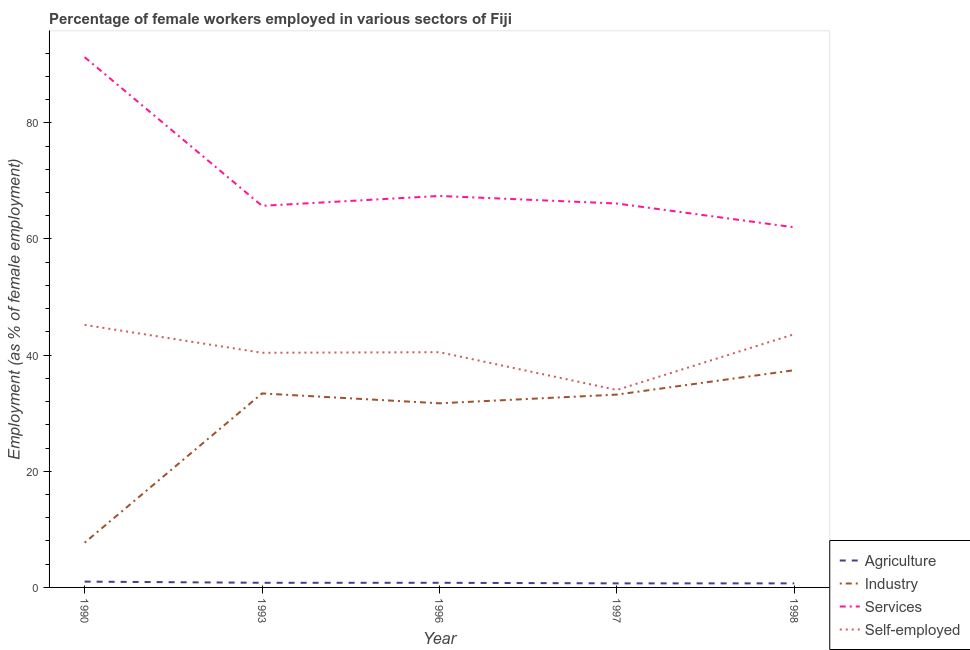How many different coloured lines are there?
Provide a short and direct response. 4. Is the number of lines equal to the number of legend labels?
Offer a terse response. Yes. What is the percentage of female workers in industry in 1998?
Offer a very short reply. 37.4. Across all years, what is the maximum percentage of self employed female workers?
Keep it short and to the point. 45.2. Across all years, what is the minimum percentage of female workers in agriculture?
Ensure brevity in your answer.  0.7. In which year was the percentage of female workers in services minimum?
Provide a short and direct response. 1998. What is the total percentage of female workers in services in the graph?
Give a very brief answer. 352.5. What is the difference between the percentage of self employed female workers in 1990 and that in 1996?
Keep it short and to the point. 4.7. What is the difference between the percentage of female workers in services in 1993 and the percentage of female workers in agriculture in 1990?
Offer a very short reply. 64.7. What is the average percentage of self employed female workers per year?
Give a very brief answer. 40.74. In the year 1993, what is the difference between the percentage of female workers in industry and percentage of female workers in services?
Keep it short and to the point. -32.3. In how many years, is the percentage of female workers in industry greater than 84 %?
Your response must be concise. 0. Is the percentage of female workers in industry in 1990 less than that in 1996?
Provide a short and direct response. Yes. Is the difference between the percentage of female workers in agriculture in 1996 and 1997 greater than the difference between the percentage of self employed female workers in 1996 and 1997?
Ensure brevity in your answer.  No. What is the difference between the highest and the second highest percentage of self employed female workers?
Keep it short and to the point. 1.6. What is the difference between the highest and the lowest percentage of female workers in agriculture?
Your answer should be very brief. 0.3. Is it the case that in every year, the sum of the percentage of self employed female workers and percentage of female workers in services is greater than the sum of percentage of female workers in agriculture and percentage of female workers in industry?
Make the answer very short. Yes. Is the percentage of female workers in industry strictly less than the percentage of female workers in agriculture over the years?
Ensure brevity in your answer.  No. What is the difference between two consecutive major ticks on the Y-axis?
Give a very brief answer. 20. Does the graph contain any zero values?
Your response must be concise. No. Does the graph contain grids?
Keep it short and to the point. No. How are the legend labels stacked?
Keep it short and to the point. Vertical. What is the title of the graph?
Your answer should be compact. Percentage of female workers employed in various sectors of Fiji. Does "Miscellaneous expenses" appear as one of the legend labels in the graph?
Your answer should be compact. No. What is the label or title of the Y-axis?
Keep it short and to the point. Employment (as % of female employment). What is the Employment (as % of female employment) of Agriculture in 1990?
Make the answer very short. 1. What is the Employment (as % of female employment) of Industry in 1990?
Make the answer very short. 7.7. What is the Employment (as % of female employment) of Services in 1990?
Ensure brevity in your answer.  91.3. What is the Employment (as % of female employment) in Self-employed in 1990?
Ensure brevity in your answer.  45.2. What is the Employment (as % of female employment) in Agriculture in 1993?
Make the answer very short. 0.8. What is the Employment (as % of female employment) in Industry in 1993?
Provide a succinct answer. 33.4. What is the Employment (as % of female employment) in Services in 1993?
Keep it short and to the point. 65.7. What is the Employment (as % of female employment) in Self-employed in 1993?
Offer a very short reply. 40.4. What is the Employment (as % of female employment) in Agriculture in 1996?
Make the answer very short. 0.8. What is the Employment (as % of female employment) of Industry in 1996?
Your answer should be very brief. 31.7. What is the Employment (as % of female employment) of Services in 1996?
Keep it short and to the point. 67.4. What is the Employment (as % of female employment) of Self-employed in 1996?
Your answer should be compact. 40.5. What is the Employment (as % of female employment) in Agriculture in 1997?
Keep it short and to the point. 0.7. What is the Employment (as % of female employment) in Industry in 1997?
Offer a very short reply. 33.2. What is the Employment (as % of female employment) of Services in 1997?
Provide a short and direct response. 66.1. What is the Employment (as % of female employment) of Self-employed in 1997?
Provide a short and direct response. 34. What is the Employment (as % of female employment) of Agriculture in 1998?
Provide a short and direct response. 0.7. What is the Employment (as % of female employment) in Industry in 1998?
Your answer should be very brief. 37.4. What is the Employment (as % of female employment) in Services in 1998?
Provide a succinct answer. 62. What is the Employment (as % of female employment) in Self-employed in 1998?
Make the answer very short. 43.6. Across all years, what is the maximum Employment (as % of female employment) of Industry?
Your response must be concise. 37.4. Across all years, what is the maximum Employment (as % of female employment) of Services?
Provide a short and direct response. 91.3. Across all years, what is the maximum Employment (as % of female employment) of Self-employed?
Provide a short and direct response. 45.2. Across all years, what is the minimum Employment (as % of female employment) in Agriculture?
Provide a short and direct response. 0.7. Across all years, what is the minimum Employment (as % of female employment) in Industry?
Your answer should be compact. 7.7. Across all years, what is the minimum Employment (as % of female employment) in Services?
Give a very brief answer. 62. What is the total Employment (as % of female employment) in Industry in the graph?
Offer a terse response. 143.4. What is the total Employment (as % of female employment) in Services in the graph?
Make the answer very short. 352.5. What is the total Employment (as % of female employment) of Self-employed in the graph?
Provide a succinct answer. 203.7. What is the difference between the Employment (as % of female employment) in Industry in 1990 and that in 1993?
Provide a succinct answer. -25.7. What is the difference between the Employment (as % of female employment) of Services in 1990 and that in 1993?
Provide a succinct answer. 25.6. What is the difference between the Employment (as % of female employment) in Industry in 1990 and that in 1996?
Your answer should be compact. -24. What is the difference between the Employment (as % of female employment) of Services in 1990 and that in 1996?
Offer a very short reply. 23.9. What is the difference between the Employment (as % of female employment) of Industry in 1990 and that in 1997?
Keep it short and to the point. -25.5. What is the difference between the Employment (as % of female employment) of Services in 1990 and that in 1997?
Your answer should be compact. 25.2. What is the difference between the Employment (as % of female employment) in Self-employed in 1990 and that in 1997?
Give a very brief answer. 11.2. What is the difference between the Employment (as % of female employment) in Industry in 1990 and that in 1998?
Provide a short and direct response. -29.7. What is the difference between the Employment (as % of female employment) of Services in 1990 and that in 1998?
Your answer should be very brief. 29.3. What is the difference between the Employment (as % of female employment) of Self-employed in 1990 and that in 1998?
Offer a terse response. 1.6. What is the difference between the Employment (as % of female employment) of Industry in 1993 and that in 1996?
Your answer should be very brief. 1.7. What is the difference between the Employment (as % of female employment) in Services in 1993 and that in 1996?
Make the answer very short. -1.7. What is the difference between the Employment (as % of female employment) in Self-employed in 1993 and that in 1997?
Ensure brevity in your answer.  6.4. What is the difference between the Employment (as % of female employment) of Services in 1993 and that in 1998?
Provide a short and direct response. 3.7. What is the difference between the Employment (as % of female employment) in Services in 1996 and that in 1997?
Ensure brevity in your answer.  1.3. What is the difference between the Employment (as % of female employment) of Services in 1996 and that in 1998?
Provide a short and direct response. 5.4. What is the difference between the Employment (as % of female employment) of Agriculture in 1997 and that in 1998?
Keep it short and to the point. 0. What is the difference between the Employment (as % of female employment) in Agriculture in 1990 and the Employment (as % of female employment) in Industry in 1993?
Offer a terse response. -32.4. What is the difference between the Employment (as % of female employment) of Agriculture in 1990 and the Employment (as % of female employment) of Services in 1993?
Ensure brevity in your answer.  -64.7. What is the difference between the Employment (as % of female employment) of Agriculture in 1990 and the Employment (as % of female employment) of Self-employed in 1993?
Give a very brief answer. -39.4. What is the difference between the Employment (as % of female employment) in Industry in 1990 and the Employment (as % of female employment) in Services in 1993?
Make the answer very short. -58. What is the difference between the Employment (as % of female employment) in Industry in 1990 and the Employment (as % of female employment) in Self-employed in 1993?
Ensure brevity in your answer.  -32.7. What is the difference between the Employment (as % of female employment) in Services in 1990 and the Employment (as % of female employment) in Self-employed in 1993?
Make the answer very short. 50.9. What is the difference between the Employment (as % of female employment) in Agriculture in 1990 and the Employment (as % of female employment) in Industry in 1996?
Keep it short and to the point. -30.7. What is the difference between the Employment (as % of female employment) in Agriculture in 1990 and the Employment (as % of female employment) in Services in 1996?
Your response must be concise. -66.4. What is the difference between the Employment (as % of female employment) of Agriculture in 1990 and the Employment (as % of female employment) of Self-employed in 1996?
Ensure brevity in your answer.  -39.5. What is the difference between the Employment (as % of female employment) of Industry in 1990 and the Employment (as % of female employment) of Services in 1996?
Your answer should be compact. -59.7. What is the difference between the Employment (as % of female employment) of Industry in 1990 and the Employment (as % of female employment) of Self-employed in 1996?
Your answer should be compact. -32.8. What is the difference between the Employment (as % of female employment) of Services in 1990 and the Employment (as % of female employment) of Self-employed in 1996?
Provide a short and direct response. 50.8. What is the difference between the Employment (as % of female employment) of Agriculture in 1990 and the Employment (as % of female employment) of Industry in 1997?
Keep it short and to the point. -32.2. What is the difference between the Employment (as % of female employment) of Agriculture in 1990 and the Employment (as % of female employment) of Services in 1997?
Offer a very short reply. -65.1. What is the difference between the Employment (as % of female employment) in Agriculture in 1990 and the Employment (as % of female employment) in Self-employed in 1997?
Your answer should be very brief. -33. What is the difference between the Employment (as % of female employment) in Industry in 1990 and the Employment (as % of female employment) in Services in 1997?
Keep it short and to the point. -58.4. What is the difference between the Employment (as % of female employment) in Industry in 1990 and the Employment (as % of female employment) in Self-employed in 1997?
Keep it short and to the point. -26.3. What is the difference between the Employment (as % of female employment) in Services in 1990 and the Employment (as % of female employment) in Self-employed in 1997?
Offer a very short reply. 57.3. What is the difference between the Employment (as % of female employment) of Agriculture in 1990 and the Employment (as % of female employment) of Industry in 1998?
Give a very brief answer. -36.4. What is the difference between the Employment (as % of female employment) in Agriculture in 1990 and the Employment (as % of female employment) in Services in 1998?
Give a very brief answer. -61. What is the difference between the Employment (as % of female employment) in Agriculture in 1990 and the Employment (as % of female employment) in Self-employed in 1998?
Give a very brief answer. -42.6. What is the difference between the Employment (as % of female employment) in Industry in 1990 and the Employment (as % of female employment) in Services in 1998?
Your response must be concise. -54.3. What is the difference between the Employment (as % of female employment) in Industry in 1990 and the Employment (as % of female employment) in Self-employed in 1998?
Your answer should be compact. -35.9. What is the difference between the Employment (as % of female employment) in Services in 1990 and the Employment (as % of female employment) in Self-employed in 1998?
Provide a short and direct response. 47.7. What is the difference between the Employment (as % of female employment) of Agriculture in 1993 and the Employment (as % of female employment) of Industry in 1996?
Make the answer very short. -30.9. What is the difference between the Employment (as % of female employment) in Agriculture in 1993 and the Employment (as % of female employment) in Services in 1996?
Offer a very short reply. -66.6. What is the difference between the Employment (as % of female employment) in Agriculture in 1993 and the Employment (as % of female employment) in Self-employed in 1996?
Offer a very short reply. -39.7. What is the difference between the Employment (as % of female employment) of Industry in 1993 and the Employment (as % of female employment) of Services in 1996?
Offer a very short reply. -34. What is the difference between the Employment (as % of female employment) of Services in 1993 and the Employment (as % of female employment) of Self-employed in 1996?
Your response must be concise. 25.2. What is the difference between the Employment (as % of female employment) of Agriculture in 1993 and the Employment (as % of female employment) of Industry in 1997?
Your answer should be very brief. -32.4. What is the difference between the Employment (as % of female employment) in Agriculture in 1993 and the Employment (as % of female employment) in Services in 1997?
Offer a terse response. -65.3. What is the difference between the Employment (as % of female employment) in Agriculture in 1993 and the Employment (as % of female employment) in Self-employed in 1997?
Provide a short and direct response. -33.2. What is the difference between the Employment (as % of female employment) in Industry in 1993 and the Employment (as % of female employment) in Services in 1997?
Provide a succinct answer. -32.7. What is the difference between the Employment (as % of female employment) in Industry in 1993 and the Employment (as % of female employment) in Self-employed in 1997?
Offer a terse response. -0.6. What is the difference between the Employment (as % of female employment) in Services in 1993 and the Employment (as % of female employment) in Self-employed in 1997?
Provide a short and direct response. 31.7. What is the difference between the Employment (as % of female employment) in Agriculture in 1993 and the Employment (as % of female employment) in Industry in 1998?
Offer a very short reply. -36.6. What is the difference between the Employment (as % of female employment) of Agriculture in 1993 and the Employment (as % of female employment) of Services in 1998?
Offer a terse response. -61.2. What is the difference between the Employment (as % of female employment) of Agriculture in 1993 and the Employment (as % of female employment) of Self-employed in 1998?
Your answer should be compact. -42.8. What is the difference between the Employment (as % of female employment) of Industry in 1993 and the Employment (as % of female employment) of Services in 1998?
Your answer should be compact. -28.6. What is the difference between the Employment (as % of female employment) of Industry in 1993 and the Employment (as % of female employment) of Self-employed in 1998?
Provide a succinct answer. -10.2. What is the difference between the Employment (as % of female employment) in Services in 1993 and the Employment (as % of female employment) in Self-employed in 1998?
Ensure brevity in your answer.  22.1. What is the difference between the Employment (as % of female employment) in Agriculture in 1996 and the Employment (as % of female employment) in Industry in 1997?
Your answer should be compact. -32.4. What is the difference between the Employment (as % of female employment) in Agriculture in 1996 and the Employment (as % of female employment) in Services in 1997?
Keep it short and to the point. -65.3. What is the difference between the Employment (as % of female employment) of Agriculture in 1996 and the Employment (as % of female employment) of Self-employed in 1997?
Give a very brief answer. -33.2. What is the difference between the Employment (as % of female employment) of Industry in 1996 and the Employment (as % of female employment) of Services in 1997?
Offer a very short reply. -34.4. What is the difference between the Employment (as % of female employment) of Services in 1996 and the Employment (as % of female employment) of Self-employed in 1997?
Give a very brief answer. 33.4. What is the difference between the Employment (as % of female employment) of Agriculture in 1996 and the Employment (as % of female employment) of Industry in 1998?
Give a very brief answer. -36.6. What is the difference between the Employment (as % of female employment) of Agriculture in 1996 and the Employment (as % of female employment) of Services in 1998?
Your response must be concise. -61.2. What is the difference between the Employment (as % of female employment) in Agriculture in 1996 and the Employment (as % of female employment) in Self-employed in 1998?
Your answer should be compact. -42.8. What is the difference between the Employment (as % of female employment) of Industry in 1996 and the Employment (as % of female employment) of Services in 1998?
Offer a terse response. -30.3. What is the difference between the Employment (as % of female employment) in Industry in 1996 and the Employment (as % of female employment) in Self-employed in 1998?
Ensure brevity in your answer.  -11.9. What is the difference between the Employment (as % of female employment) of Services in 1996 and the Employment (as % of female employment) of Self-employed in 1998?
Your response must be concise. 23.8. What is the difference between the Employment (as % of female employment) in Agriculture in 1997 and the Employment (as % of female employment) in Industry in 1998?
Provide a short and direct response. -36.7. What is the difference between the Employment (as % of female employment) in Agriculture in 1997 and the Employment (as % of female employment) in Services in 1998?
Offer a terse response. -61.3. What is the difference between the Employment (as % of female employment) in Agriculture in 1997 and the Employment (as % of female employment) in Self-employed in 1998?
Offer a terse response. -42.9. What is the difference between the Employment (as % of female employment) of Industry in 1997 and the Employment (as % of female employment) of Services in 1998?
Provide a succinct answer. -28.8. What is the difference between the Employment (as % of female employment) of Services in 1997 and the Employment (as % of female employment) of Self-employed in 1998?
Offer a very short reply. 22.5. What is the average Employment (as % of female employment) of Industry per year?
Provide a short and direct response. 28.68. What is the average Employment (as % of female employment) of Services per year?
Your response must be concise. 70.5. What is the average Employment (as % of female employment) of Self-employed per year?
Provide a succinct answer. 40.74. In the year 1990, what is the difference between the Employment (as % of female employment) of Agriculture and Employment (as % of female employment) of Industry?
Your response must be concise. -6.7. In the year 1990, what is the difference between the Employment (as % of female employment) of Agriculture and Employment (as % of female employment) of Services?
Your response must be concise. -90.3. In the year 1990, what is the difference between the Employment (as % of female employment) of Agriculture and Employment (as % of female employment) of Self-employed?
Ensure brevity in your answer.  -44.2. In the year 1990, what is the difference between the Employment (as % of female employment) in Industry and Employment (as % of female employment) in Services?
Make the answer very short. -83.6. In the year 1990, what is the difference between the Employment (as % of female employment) of Industry and Employment (as % of female employment) of Self-employed?
Your answer should be very brief. -37.5. In the year 1990, what is the difference between the Employment (as % of female employment) in Services and Employment (as % of female employment) in Self-employed?
Make the answer very short. 46.1. In the year 1993, what is the difference between the Employment (as % of female employment) in Agriculture and Employment (as % of female employment) in Industry?
Your response must be concise. -32.6. In the year 1993, what is the difference between the Employment (as % of female employment) of Agriculture and Employment (as % of female employment) of Services?
Keep it short and to the point. -64.9. In the year 1993, what is the difference between the Employment (as % of female employment) of Agriculture and Employment (as % of female employment) of Self-employed?
Your answer should be very brief. -39.6. In the year 1993, what is the difference between the Employment (as % of female employment) of Industry and Employment (as % of female employment) of Services?
Provide a short and direct response. -32.3. In the year 1993, what is the difference between the Employment (as % of female employment) in Services and Employment (as % of female employment) in Self-employed?
Give a very brief answer. 25.3. In the year 1996, what is the difference between the Employment (as % of female employment) in Agriculture and Employment (as % of female employment) in Industry?
Your answer should be very brief. -30.9. In the year 1996, what is the difference between the Employment (as % of female employment) of Agriculture and Employment (as % of female employment) of Services?
Ensure brevity in your answer.  -66.6. In the year 1996, what is the difference between the Employment (as % of female employment) in Agriculture and Employment (as % of female employment) in Self-employed?
Keep it short and to the point. -39.7. In the year 1996, what is the difference between the Employment (as % of female employment) of Industry and Employment (as % of female employment) of Services?
Offer a terse response. -35.7. In the year 1996, what is the difference between the Employment (as % of female employment) of Industry and Employment (as % of female employment) of Self-employed?
Offer a very short reply. -8.8. In the year 1996, what is the difference between the Employment (as % of female employment) of Services and Employment (as % of female employment) of Self-employed?
Offer a terse response. 26.9. In the year 1997, what is the difference between the Employment (as % of female employment) of Agriculture and Employment (as % of female employment) of Industry?
Give a very brief answer. -32.5. In the year 1997, what is the difference between the Employment (as % of female employment) in Agriculture and Employment (as % of female employment) in Services?
Offer a very short reply. -65.4. In the year 1997, what is the difference between the Employment (as % of female employment) in Agriculture and Employment (as % of female employment) in Self-employed?
Offer a very short reply. -33.3. In the year 1997, what is the difference between the Employment (as % of female employment) of Industry and Employment (as % of female employment) of Services?
Your answer should be compact. -32.9. In the year 1997, what is the difference between the Employment (as % of female employment) in Industry and Employment (as % of female employment) in Self-employed?
Provide a succinct answer. -0.8. In the year 1997, what is the difference between the Employment (as % of female employment) in Services and Employment (as % of female employment) in Self-employed?
Your answer should be very brief. 32.1. In the year 1998, what is the difference between the Employment (as % of female employment) in Agriculture and Employment (as % of female employment) in Industry?
Offer a very short reply. -36.7. In the year 1998, what is the difference between the Employment (as % of female employment) in Agriculture and Employment (as % of female employment) in Services?
Offer a terse response. -61.3. In the year 1998, what is the difference between the Employment (as % of female employment) in Agriculture and Employment (as % of female employment) in Self-employed?
Provide a succinct answer. -42.9. In the year 1998, what is the difference between the Employment (as % of female employment) of Industry and Employment (as % of female employment) of Services?
Provide a succinct answer. -24.6. What is the ratio of the Employment (as % of female employment) in Industry in 1990 to that in 1993?
Your answer should be very brief. 0.23. What is the ratio of the Employment (as % of female employment) of Services in 1990 to that in 1993?
Offer a very short reply. 1.39. What is the ratio of the Employment (as % of female employment) of Self-employed in 1990 to that in 1993?
Keep it short and to the point. 1.12. What is the ratio of the Employment (as % of female employment) of Agriculture in 1990 to that in 1996?
Offer a terse response. 1.25. What is the ratio of the Employment (as % of female employment) of Industry in 1990 to that in 1996?
Provide a succinct answer. 0.24. What is the ratio of the Employment (as % of female employment) in Services in 1990 to that in 1996?
Your response must be concise. 1.35. What is the ratio of the Employment (as % of female employment) in Self-employed in 1990 to that in 1996?
Your response must be concise. 1.12. What is the ratio of the Employment (as % of female employment) of Agriculture in 1990 to that in 1997?
Give a very brief answer. 1.43. What is the ratio of the Employment (as % of female employment) of Industry in 1990 to that in 1997?
Your answer should be compact. 0.23. What is the ratio of the Employment (as % of female employment) of Services in 1990 to that in 1997?
Offer a terse response. 1.38. What is the ratio of the Employment (as % of female employment) of Self-employed in 1990 to that in 1997?
Your answer should be very brief. 1.33. What is the ratio of the Employment (as % of female employment) of Agriculture in 1990 to that in 1998?
Give a very brief answer. 1.43. What is the ratio of the Employment (as % of female employment) in Industry in 1990 to that in 1998?
Offer a very short reply. 0.21. What is the ratio of the Employment (as % of female employment) of Services in 1990 to that in 1998?
Offer a terse response. 1.47. What is the ratio of the Employment (as % of female employment) of Self-employed in 1990 to that in 1998?
Your answer should be compact. 1.04. What is the ratio of the Employment (as % of female employment) in Industry in 1993 to that in 1996?
Provide a succinct answer. 1.05. What is the ratio of the Employment (as % of female employment) of Services in 1993 to that in 1996?
Keep it short and to the point. 0.97. What is the ratio of the Employment (as % of female employment) in Agriculture in 1993 to that in 1997?
Your answer should be very brief. 1.14. What is the ratio of the Employment (as % of female employment) of Services in 1993 to that in 1997?
Give a very brief answer. 0.99. What is the ratio of the Employment (as % of female employment) in Self-employed in 1993 to that in 1997?
Make the answer very short. 1.19. What is the ratio of the Employment (as % of female employment) of Agriculture in 1993 to that in 1998?
Give a very brief answer. 1.14. What is the ratio of the Employment (as % of female employment) in Industry in 1993 to that in 1998?
Give a very brief answer. 0.89. What is the ratio of the Employment (as % of female employment) in Services in 1993 to that in 1998?
Give a very brief answer. 1.06. What is the ratio of the Employment (as % of female employment) of Self-employed in 1993 to that in 1998?
Give a very brief answer. 0.93. What is the ratio of the Employment (as % of female employment) of Industry in 1996 to that in 1997?
Provide a short and direct response. 0.95. What is the ratio of the Employment (as % of female employment) of Services in 1996 to that in 1997?
Give a very brief answer. 1.02. What is the ratio of the Employment (as % of female employment) of Self-employed in 1996 to that in 1997?
Your answer should be very brief. 1.19. What is the ratio of the Employment (as % of female employment) of Industry in 1996 to that in 1998?
Offer a terse response. 0.85. What is the ratio of the Employment (as % of female employment) in Services in 1996 to that in 1998?
Offer a very short reply. 1.09. What is the ratio of the Employment (as % of female employment) of Self-employed in 1996 to that in 1998?
Your answer should be compact. 0.93. What is the ratio of the Employment (as % of female employment) in Industry in 1997 to that in 1998?
Your answer should be compact. 0.89. What is the ratio of the Employment (as % of female employment) in Services in 1997 to that in 1998?
Keep it short and to the point. 1.07. What is the ratio of the Employment (as % of female employment) of Self-employed in 1997 to that in 1998?
Ensure brevity in your answer.  0.78. What is the difference between the highest and the second highest Employment (as % of female employment) of Agriculture?
Offer a very short reply. 0.2. What is the difference between the highest and the second highest Employment (as % of female employment) of Industry?
Your answer should be compact. 4. What is the difference between the highest and the second highest Employment (as % of female employment) in Services?
Your response must be concise. 23.9. What is the difference between the highest and the lowest Employment (as % of female employment) of Agriculture?
Offer a terse response. 0.3. What is the difference between the highest and the lowest Employment (as % of female employment) of Industry?
Your response must be concise. 29.7. What is the difference between the highest and the lowest Employment (as % of female employment) in Services?
Provide a short and direct response. 29.3. 